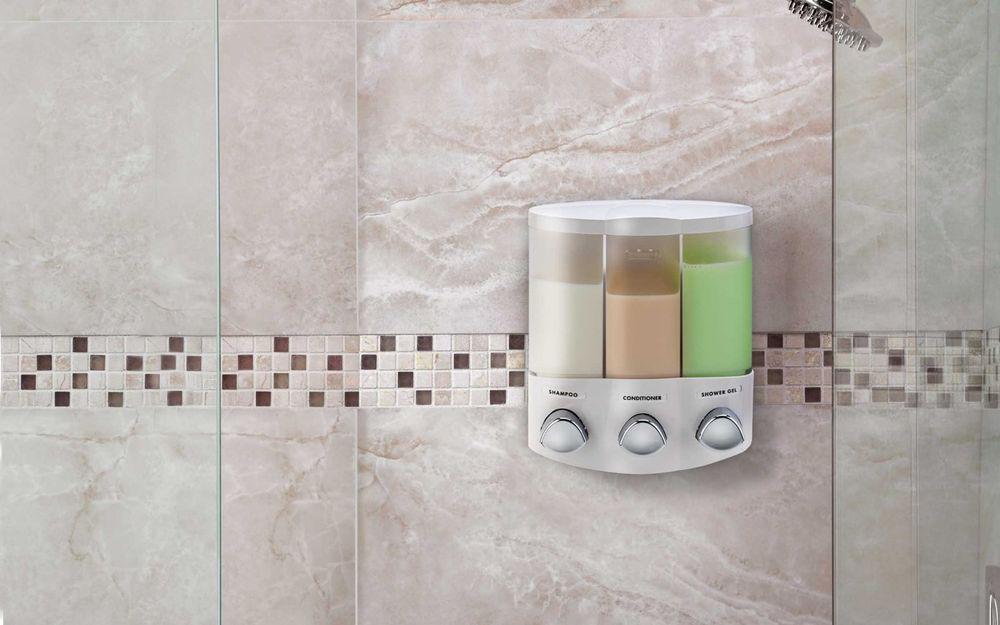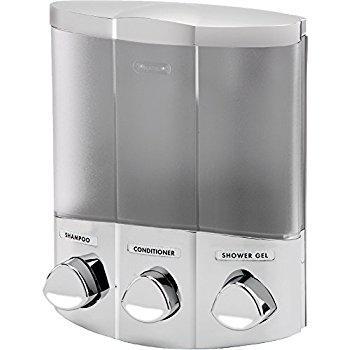The first image is the image on the left, the second image is the image on the right. For the images shown, is this caption "The right image contains a soap dispenser and the soap container the furthest to the right is bright green." true? Answer yes or no. No. 